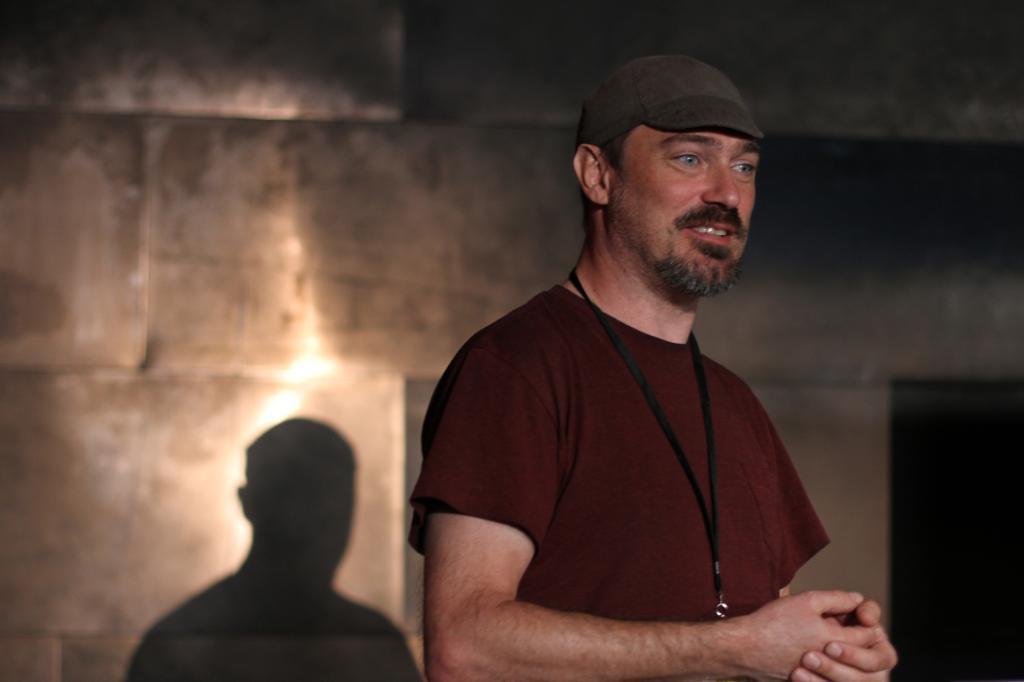Could you give a brief overview of what you see in this image? This image consists of a man wearing a brown T-shirt. He is also wearing a cap. In the background, there is a wall on which we can see a shadow. On the right, it looks like a door. 